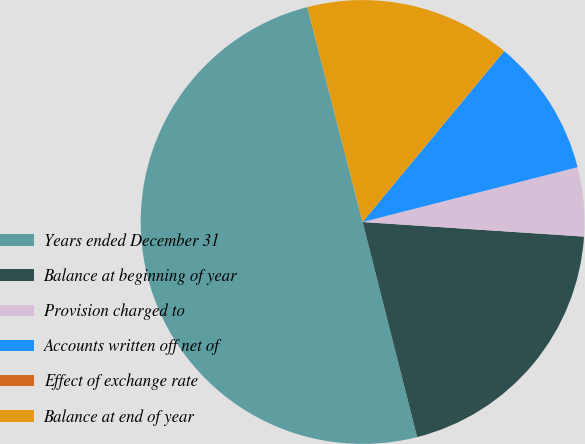Convert chart. <chart><loc_0><loc_0><loc_500><loc_500><pie_chart><fcel>Years ended December 31<fcel>Balance at beginning of year<fcel>Provision charged to<fcel>Accounts written off net of<fcel>Effect of exchange rate<fcel>Balance at end of year<nl><fcel>49.95%<fcel>20.0%<fcel>5.02%<fcel>10.01%<fcel>0.02%<fcel>15.0%<nl></chart> 